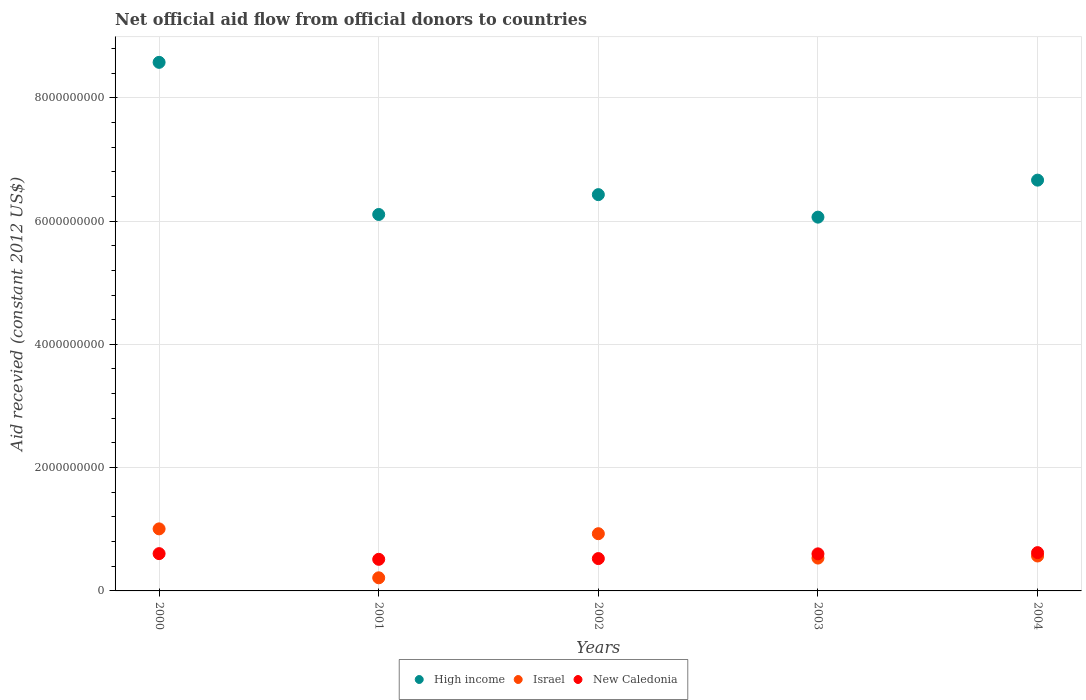What is the total aid received in New Caledonia in 2004?
Your answer should be compact. 6.21e+08. Across all years, what is the maximum total aid received in Israel?
Ensure brevity in your answer.  1.01e+09. Across all years, what is the minimum total aid received in High income?
Provide a succinct answer. 6.06e+09. In which year was the total aid received in High income maximum?
Offer a terse response. 2000. What is the total total aid received in New Caledonia in the graph?
Your response must be concise. 2.86e+09. What is the difference between the total aid received in High income in 2000 and that in 2001?
Your answer should be compact. 2.47e+09. What is the difference between the total aid received in New Caledonia in 2004 and the total aid received in High income in 2001?
Make the answer very short. -5.49e+09. What is the average total aid received in New Caledonia per year?
Offer a terse response. 5.73e+08. In the year 2000, what is the difference between the total aid received in New Caledonia and total aid received in High income?
Offer a terse response. -7.97e+09. In how many years, is the total aid received in High income greater than 2800000000 US$?
Offer a terse response. 5. What is the ratio of the total aid received in New Caledonia in 2000 to that in 2003?
Provide a succinct answer. 1.01. Is the total aid received in New Caledonia in 2001 less than that in 2003?
Your answer should be very brief. Yes. Is the difference between the total aid received in New Caledonia in 2000 and 2003 greater than the difference between the total aid received in High income in 2000 and 2003?
Your answer should be compact. No. What is the difference between the highest and the second highest total aid received in High income?
Keep it short and to the point. 1.91e+09. What is the difference between the highest and the lowest total aid received in High income?
Provide a succinct answer. 2.51e+09. In how many years, is the total aid received in Israel greater than the average total aid received in Israel taken over all years?
Your response must be concise. 2. Is the sum of the total aid received in New Caledonia in 2001 and 2004 greater than the maximum total aid received in High income across all years?
Make the answer very short. No. How many dotlines are there?
Keep it short and to the point. 3. Are the values on the major ticks of Y-axis written in scientific E-notation?
Your response must be concise. No. Does the graph contain any zero values?
Your answer should be compact. No. How are the legend labels stacked?
Ensure brevity in your answer.  Horizontal. What is the title of the graph?
Provide a succinct answer. Net official aid flow from official donors to countries. Does "Czech Republic" appear as one of the legend labels in the graph?
Make the answer very short. No. What is the label or title of the X-axis?
Your answer should be very brief. Years. What is the label or title of the Y-axis?
Offer a very short reply. Aid recevied (constant 2012 US$). What is the Aid recevied (constant 2012 US$) of High income in 2000?
Ensure brevity in your answer.  8.57e+09. What is the Aid recevied (constant 2012 US$) in Israel in 2000?
Make the answer very short. 1.01e+09. What is the Aid recevied (constant 2012 US$) of New Caledonia in 2000?
Your answer should be very brief. 6.05e+08. What is the Aid recevied (constant 2012 US$) of High income in 2001?
Provide a succinct answer. 6.11e+09. What is the Aid recevied (constant 2012 US$) in Israel in 2001?
Offer a very short reply. 2.13e+08. What is the Aid recevied (constant 2012 US$) of New Caledonia in 2001?
Offer a very short reply. 5.13e+08. What is the Aid recevied (constant 2012 US$) in High income in 2002?
Offer a very short reply. 6.43e+09. What is the Aid recevied (constant 2012 US$) in Israel in 2002?
Your answer should be very brief. 9.28e+08. What is the Aid recevied (constant 2012 US$) of New Caledonia in 2002?
Ensure brevity in your answer.  5.25e+08. What is the Aid recevied (constant 2012 US$) of High income in 2003?
Give a very brief answer. 6.06e+09. What is the Aid recevied (constant 2012 US$) in Israel in 2003?
Your answer should be compact. 5.33e+08. What is the Aid recevied (constant 2012 US$) in New Caledonia in 2003?
Offer a very short reply. 6.01e+08. What is the Aid recevied (constant 2012 US$) of High income in 2004?
Offer a very short reply. 6.66e+09. What is the Aid recevied (constant 2012 US$) of Israel in 2004?
Offer a terse response. 5.66e+08. What is the Aid recevied (constant 2012 US$) of New Caledonia in 2004?
Provide a short and direct response. 6.21e+08. Across all years, what is the maximum Aid recevied (constant 2012 US$) of High income?
Keep it short and to the point. 8.57e+09. Across all years, what is the maximum Aid recevied (constant 2012 US$) in Israel?
Keep it short and to the point. 1.01e+09. Across all years, what is the maximum Aid recevied (constant 2012 US$) of New Caledonia?
Offer a terse response. 6.21e+08. Across all years, what is the minimum Aid recevied (constant 2012 US$) of High income?
Provide a succinct answer. 6.06e+09. Across all years, what is the minimum Aid recevied (constant 2012 US$) of Israel?
Make the answer very short. 2.13e+08. Across all years, what is the minimum Aid recevied (constant 2012 US$) in New Caledonia?
Ensure brevity in your answer.  5.13e+08. What is the total Aid recevied (constant 2012 US$) of High income in the graph?
Offer a terse response. 3.38e+1. What is the total Aid recevied (constant 2012 US$) in Israel in the graph?
Provide a short and direct response. 3.25e+09. What is the total Aid recevied (constant 2012 US$) in New Caledonia in the graph?
Provide a succinct answer. 2.86e+09. What is the difference between the Aid recevied (constant 2012 US$) in High income in 2000 and that in 2001?
Your response must be concise. 2.47e+09. What is the difference between the Aid recevied (constant 2012 US$) of Israel in 2000 and that in 2001?
Make the answer very short. 7.94e+08. What is the difference between the Aid recevied (constant 2012 US$) in New Caledonia in 2000 and that in 2001?
Provide a succinct answer. 9.23e+07. What is the difference between the Aid recevied (constant 2012 US$) in High income in 2000 and that in 2002?
Keep it short and to the point. 2.15e+09. What is the difference between the Aid recevied (constant 2012 US$) of Israel in 2000 and that in 2002?
Offer a very short reply. 7.83e+07. What is the difference between the Aid recevied (constant 2012 US$) of New Caledonia in 2000 and that in 2002?
Your answer should be very brief. 8.02e+07. What is the difference between the Aid recevied (constant 2012 US$) of High income in 2000 and that in 2003?
Keep it short and to the point. 2.51e+09. What is the difference between the Aid recevied (constant 2012 US$) in Israel in 2000 and that in 2003?
Your answer should be compact. 4.74e+08. What is the difference between the Aid recevied (constant 2012 US$) in New Caledonia in 2000 and that in 2003?
Give a very brief answer. 3.50e+06. What is the difference between the Aid recevied (constant 2012 US$) of High income in 2000 and that in 2004?
Make the answer very short. 1.91e+09. What is the difference between the Aid recevied (constant 2012 US$) of Israel in 2000 and that in 2004?
Your response must be concise. 4.40e+08. What is the difference between the Aid recevied (constant 2012 US$) in New Caledonia in 2000 and that in 2004?
Give a very brief answer. -1.62e+07. What is the difference between the Aid recevied (constant 2012 US$) in High income in 2001 and that in 2002?
Make the answer very short. -3.22e+08. What is the difference between the Aid recevied (constant 2012 US$) of Israel in 2001 and that in 2002?
Your answer should be very brief. -7.15e+08. What is the difference between the Aid recevied (constant 2012 US$) of New Caledonia in 2001 and that in 2002?
Offer a terse response. -1.21e+07. What is the difference between the Aid recevied (constant 2012 US$) of High income in 2001 and that in 2003?
Make the answer very short. 4.32e+07. What is the difference between the Aid recevied (constant 2012 US$) in Israel in 2001 and that in 2003?
Provide a succinct answer. -3.20e+08. What is the difference between the Aid recevied (constant 2012 US$) of New Caledonia in 2001 and that in 2003?
Keep it short and to the point. -8.88e+07. What is the difference between the Aid recevied (constant 2012 US$) of High income in 2001 and that in 2004?
Your response must be concise. -5.57e+08. What is the difference between the Aid recevied (constant 2012 US$) of Israel in 2001 and that in 2004?
Give a very brief answer. -3.54e+08. What is the difference between the Aid recevied (constant 2012 US$) of New Caledonia in 2001 and that in 2004?
Make the answer very short. -1.08e+08. What is the difference between the Aid recevied (constant 2012 US$) in High income in 2002 and that in 2003?
Your answer should be very brief. 3.65e+08. What is the difference between the Aid recevied (constant 2012 US$) in Israel in 2002 and that in 2003?
Keep it short and to the point. 3.95e+08. What is the difference between the Aid recevied (constant 2012 US$) in New Caledonia in 2002 and that in 2003?
Your answer should be very brief. -7.67e+07. What is the difference between the Aid recevied (constant 2012 US$) of High income in 2002 and that in 2004?
Your answer should be very brief. -2.35e+08. What is the difference between the Aid recevied (constant 2012 US$) in Israel in 2002 and that in 2004?
Your answer should be compact. 3.62e+08. What is the difference between the Aid recevied (constant 2012 US$) of New Caledonia in 2002 and that in 2004?
Give a very brief answer. -9.64e+07. What is the difference between the Aid recevied (constant 2012 US$) of High income in 2003 and that in 2004?
Provide a short and direct response. -6.00e+08. What is the difference between the Aid recevied (constant 2012 US$) in Israel in 2003 and that in 2004?
Give a very brief answer. -3.36e+07. What is the difference between the Aid recevied (constant 2012 US$) in New Caledonia in 2003 and that in 2004?
Your response must be concise. -1.97e+07. What is the difference between the Aid recevied (constant 2012 US$) of High income in 2000 and the Aid recevied (constant 2012 US$) of Israel in 2001?
Offer a very short reply. 8.36e+09. What is the difference between the Aid recevied (constant 2012 US$) of High income in 2000 and the Aid recevied (constant 2012 US$) of New Caledonia in 2001?
Offer a very short reply. 8.06e+09. What is the difference between the Aid recevied (constant 2012 US$) in Israel in 2000 and the Aid recevied (constant 2012 US$) in New Caledonia in 2001?
Your answer should be compact. 4.94e+08. What is the difference between the Aid recevied (constant 2012 US$) in High income in 2000 and the Aid recevied (constant 2012 US$) in Israel in 2002?
Ensure brevity in your answer.  7.65e+09. What is the difference between the Aid recevied (constant 2012 US$) in High income in 2000 and the Aid recevied (constant 2012 US$) in New Caledonia in 2002?
Offer a terse response. 8.05e+09. What is the difference between the Aid recevied (constant 2012 US$) in Israel in 2000 and the Aid recevied (constant 2012 US$) in New Caledonia in 2002?
Keep it short and to the point. 4.82e+08. What is the difference between the Aid recevied (constant 2012 US$) of High income in 2000 and the Aid recevied (constant 2012 US$) of Israel in 2003?
Provide a short and direct response. 8.04e+09. What is the difference between the Aid recevied (constant 2012 US$) of High income in 2000 and the Aid recevied (constant 2012 US$) of New Caledonia in 2003?
Your answer should be very brief. 7.97e+09. What is the difference between the Aid recevied (constant 2012 US$) of Israel in 2000 and the Aid recevied (constant 2012 US$) of New Caledonia in 2003?
Ensure brevity in your answer.  4.05e+08. What is the difference between the Aid recevied (constant 2012 US$) of High income in 2000 and the Aid recevied (constant 2012 US$) of Israel in 2004?
Your response must be concise. 8.01e+09. What is the difference between the Aid recevied (constant 2012 US$) of High income in 2000 and the Aid recevied (constant 2012 US$) of New Caledonia in 2004?
Your answer should be compact. 7.95e+09. What is the difference between the Aid recevied (constant 2012 US$) in Israel in 2000 and the Aid recevied (constant 2012 US$) in New Caledonia in 2004?
Your answer should be very brief. 3.85e+08. What is the difference between the Aid recevied (constant 2012 US$) of High income in 2001 and the Aid recevied (constant 2012 US$) of Israel in 2002?
Give a very brief answer. 5.18e+09. What is the difference between the Aid recevied (constant 2012 US$) in High income in 2001 and the Aid recevied (constant 2012 US$) in New Caledonia in 2002?
Offer a very short reply. 5.58e+09. What is the difference between the Aid recevied (constant 2012 US$) in Israel in 2001 and the Aid recevied (constant 2012 US$) in New Caledonia in 2002?
Your answer should be compact. -3.12e+08. What is the difference between the Aid recevied (constant 2012 US$) of High income in 2001 and the Aid recevied (constant 2012 US$) of Israel in 2003?
Offer a very short reply. 5.57e+09. What is the difference between the Aid recevied (constant 2012 US$) in High income in 2001 and the Aid recevied (constant 2012 US$) in New Caledonia in 2003?
Keep it short and to the point. 5.50e+09. What is the difference between the Aid recevied (constant 2012 US$) of Israel in 2001 and the Aid recevied (constant 2012 US$) of New Caledonia in 2003?
Provide a succinct answer. -3.88e+08. What is the difference between the Aid recevied (constant 2012 US$) in High income in 2001 and the Aid recevied (constant 2012 US$) in Israel in 2004?
Offer a very short reply. 5.54e+09. What is the difference between the Aid recevied (constant 2012 US$) in High income in 2001 and the Aid recevied (constant 2012 US$) in New Caledonia in 2004?
Your answer should be very brief. 5.49e+09. What is the difference between the Aid recevied (constant 2012 US$) of Israel in 2001 and the Aid recevied (constant 2012 US$) of New Caledonia in 2004?
Make the answer very short. -4.08e+08. What is the difference between the Aid recevied (constant 2012 US$) of High income in 2002 and the Aid recevied (constant 2012 US$) of Israel in 2003?
Your response must be concise. 5.90e+09. What is the difference between the Aid recevied (constant 2012 US$) of High income in 2002 and the Aid recevied (constant 2012 US$) of New Caledonia in 2003?
Your answer should be very brief. 5.83e+09. What is the difference between the Aid recevied (constant 2012 US$) in Israel in 2002 and the Aid recevied (constant 2012 US$) in New Caledonia in 2003?
Make the answer very short. 3.27e+08. What is the difference between the Aid recevied (constant 2012 US$) in High income in 2002 and the Aid recevied (constant 2012 US$) in Israel in 2004?
Keep it short and to the point. 5.86e+09. What is the difference between the Aid recevied (constant 2012 US$) in High income in 2002 and the Aid recevied (constant 2012 US$) in New Caledonia in 2004?
Your response must be concise. 5.81e+09. What is the difference between the Aid recevied (constant 2012 US$) of Israel in 2002 and the Aid recevied (constant 2012 US$) of New Caledonia in 2004?
Your response must be concise. 3.07e+08. What is the difference between the Aid recevied (constant 2012 US$) of High income in 2003 and the Aid recevied (constant 2012 US$) of Israel in 2004?
Keep it short and to the point. 5.50e+09. What is the difference between the Aid recevied (constant 2012 US$) of High income in 2003 and the Aid recevied (constant 2012 US$) of New Caledonia in 2004?
Provide a succinct answer. 5.44e+09. What is the difference between the Aid recevied (constant 2012 US$) of Israel in 2003 and the Aid recevied (constant 2012 US$) of New Caledonia in 2004?
Offer a terse response. -8.82e+07. What is the average Aid recevied (constant 2012 US$) of High income per year?
Ensure brevity in your answer.  6.77e+09. What is the average Aid recevied (constant 2012 US$) of Israel per year?
Your response must be concise. 6.49e+08. What is the average Aid recevied (constant 2012 US$) in New Caledonia per year?
Give a very brief answer. 5.73e+08. In the year 2000, what is the difference between the Aid recevied (constant 2012 US$) in High income and Aid recevied (constant 2012 US$) in Israel?
Give a very brief answer. 7.57e+09. In the year 2000, what is the difference between the Aid recevied (constant 2012 US$) in High income and Aid recevied (constant 2012 US$) in New Caledonia?
Your answer should be very brief. 7.97e+09. In the year 2000, what is the difference between the Aid recevied (constant 2012 US$) of Israel and Aid recevied (constant 2012 US$) of New Caledonia?
Ensure brevity in your answer.  4.02e+08. In the year 2001, what is the difference between the Aid recevied (constant 2012 US$) in High income and Aid recevied (constant 2012 US$) in Israel?
Keep it short and to the point. 5.89e+09. In the year 2001, what is the difference between the Aid recevied (constant 2012 US$) in High income and Aid recevied (constant 2012 US$) in New Caledonia?
Provide a short and direct response. 5.59e+09. In the year 2001, what is the difference between the Aid recevied (constant 2012 US$) in Israel and Aid recevied (constant 2012 US$) in New Caledonia?
Keep it short and to the point. -3.00e+08. In the year 2002, what is the difference between the Aid recevied (constant 2012 US$) in High income and Aid recevied (constant 2012 US$) in Israel?
Offer a terse response. 5.50e+09. In the year 2002, what is the difference between the Aid recevied (constant 2012 US$) of High income and Aid recevied (constant 2012 US$) of New Caledonia?
Your answer should be very brief. 5.90e+09. In the year 2002, what is the difference between the Aid recevied (constant 2012 US$) in Israel and Aid recevied (constant 2012 US$) in New Caledonia?
Offer a very short reply. 4.04e+08. In the year 2003, what is the difference between the Aid recevied (constant 2012 US$) in High income and Aid recevied (constant 2012 US$) in Israel?
Ensure brevity in your answer.  5.53e+09. In the year 2003, what is the difference between the Aid recevied (constant 2012 US$) in High income and Aid recevied (constant 2012 US$) in New Caledonia?
Your answer should be compact. 5.46e+09. In the year 2003, what is the difference between the Aid recevied (constant 2012 US$) in Israel and Aid recevied (constant 2012 US$) in New Caledonia?
Provide a short and direct response. -6.85e+07. In the year 2004, what is the difference between the Aid recevied (constant 2012 US$) in High income and Aid recevied (constant 2012 US$) in Israel?
Make the answer very short. 6.10e+09. In the year 2004, what is the difference between the Aid recevied (constant 2012 US$) in High income and Aid recevied (constant 2012 US$) in New Caledonia?
Provide a short and direct response. 6.04e+09. In the year 2004, what is the difference between the Aid recevied (constant 2012 US$) of Israel and Aid recevied (constant 2012 US$) of New Caledonia?
Your answer should be compact. -5.46e+07. What is the ratio of the Aid recevied (constant 2012 US$) of High income in 2000 to that in 2001?
Offer a very short reply. 1.4. What is the ratio of the Aid recevied (constant 2012 US$) in Israel in 2000 to that in 2001?
Offer a terse response. 4.73. What is the ratio of the Aid recevied (constant 2012 US$) of New Caledonia in 2000 to that in 2001?
Ensure brevity in your answer.  1.18. What is the ratio of the Aid recevied (constant 2012 US$) in High income in 2000 to that in 2002?
Provide a succinct answer. 1.33. What is the ratio of the Aid recevied (constant 2012 US$) in Israel in 2000 to that in 2002?
Offer a terse response. 1.08. What is the ratio of the Aid recevied (constant 2012 US$) in New Caledonia in 2000 to that in 2002?
Keep it short and to the point. 1.15. What is the ratio of the Aid recevied (constant 2012 US$) in High income in 2000 to that in 2003?
Give a very brief answer. 1.41. What is the ratio of the Aid recevied (constant 2012 US$) in Israel in 2000 to that in 2003?
Offer a very short reply. 1.89. What is the ratio of the Aid recevied (constant 2012 US$) of High income in 2000 to that in 2004?
Provide a short and direct response. 1.29. What is the ratio of the Aid recevied (constant 2012 US$) in Israel in 2000 to that in 2004?
Provide a short and direct response. 1.78. What is the ratio of the Aid recevied (constant 2012 US$) of New Caledonia in 2000 to that in 2004?
Ensure brevity in your answer.  0.97. What is the ratio of the Aid recevied (constant 2012 US$) of High income in 2001 to that in 2002?
Ensure brevity in your answer.  0.95. What is the ratio of the Aid recevied (constant 2012 US$) in Israel in 2001 to that in 2002?
Make the answer very short. 0.23. What is the ratio of the Aid recevied (constant 2012 US$) of New Caledonia in 2001 to that in 2002?
Your answer should be compact. 0.98. What is the ratio of the Aid recevied (constant 2012 US$) of High income in 2001 to that in 2003?
Your answer should be very brief. 1.01. What is the ratio of the Aid recevied (constant 2012 US$) of Israel in 2001 to that in 2003?
Keep it short and to the point. 0.4. What is the ratio of the Aid recevied (constant 2012 US$) in New Caledonia in 2001 to that in 2003?
Your answer should be compact. 0.85. What is the ratio of the Aid recevied (constant 2012 US$) in High income in 2001 to that in 2004?
Provide a short and direct response. 0.92. What is the ratio of the Aid recevied (constant 2012 US$) of Israel in 2001 to that in 2004?
Keep it short and to the point. 0.38. What is the ratio of the Aid recevied (constant 2012 US$) in New Caledonia in 2001 to that in 2004?
Ensure brevity in your answer.  0.83. What is the ratio of the Aid recevied (constant 2012 US$) in High income in 2002 to that in 2003?
Provide a short and direct response. 1.06. What is the ratio of the Aid recevied (constant 2012 US$) of Israel in 2002 to that in 2003?
Offer a very short reply. 1.74. What is the ratio of the Aid recevied (constant 2012 US$) of New Caledonia in 2002 to that in 2003?
Make the answer very short. 0.87. What is the ratio of the Aid recevied (constant 2012 US$) in High income in 2002 to that in 2004?
Your answer should be compact. 0.96. What is the ratio of the Aid recevied (constant 2012 US$) of Israel in 2002 to that in 2004?
Your answer should be compact. 1.64. What is the ratio of the Aid recevied (constant 2012 US$) in New Caledonia in 2002 to that in 2004?
Make the answer very short. 0.84. What is the ratio of the Aid recevied (constant 2012 US$) of High income in 2003 to that in 2004?
Provide a succinct answer. 0.91. What is the ratio of the Aid recevied (constant 2012 US$) in Israel in 2003 to that in 2004?
Give a very brief answer. 0.94. What is the ratio of the Aid recevied (constant 2012 US$) of New Caledonia in 2003 to that in 2004?
Provide a short and direct response. 0.97. What is the difference between the highest and the second highest Aid recevied (constant 2012 US$) of High income?
Your response must be concise. 1.91e+09. What is the difference between the highest and the second highest Aid recevied (constant 2012 US$) in Israel?
Keep it short and to the point. 7.83e+07. What is the difference between the highest and the second highest Aid recevied (constant 2012 US$) of New Caledonia?
Make the answer very short. 1.62e+07. What is the difference between the highest and the lowest Aid recevied (constant 2012 US$) in High income?
Your response must be concise. 2.51e+09. What is the difference between the highest and the lowest Aid recevied (constant 2012 US$) of Israel?
Make the answer very short. 7.94e+08. What is the difference between the highest and the lowest Aid recevied (constant 2012 US$) in New Caledonia?
Provide a short and direct response. 1.08e+08. 